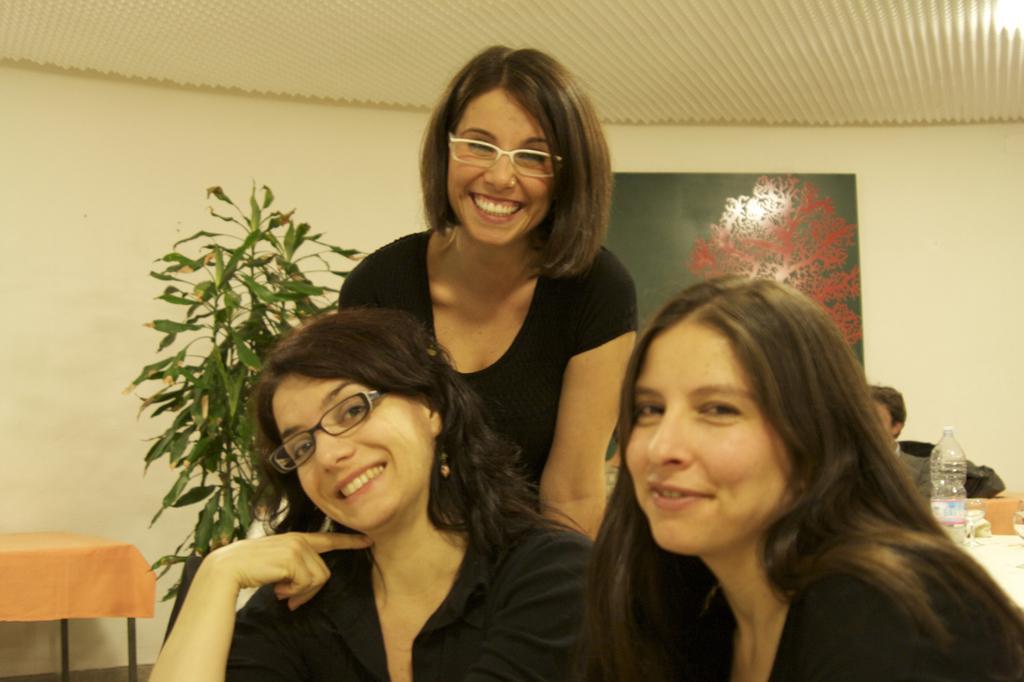In one or two sentences, can you explain what this image depicts? In this image I can see three people. To the right of these people there is a plant. In the background there is a board attached to the wall. 